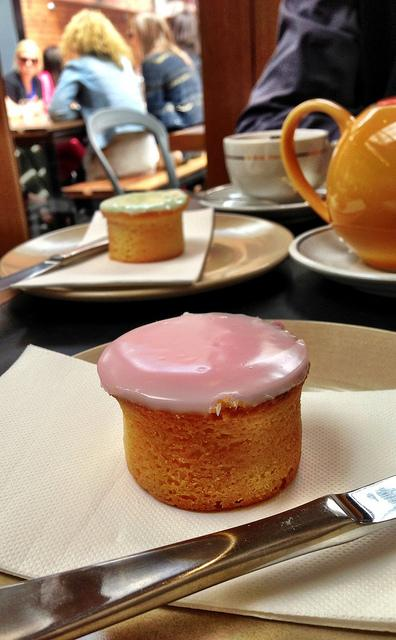What kitchen cooker is necessary for this treat's preparation?

Choices:
A) stove top
B) fryer
C) open fire
D) oven oven 